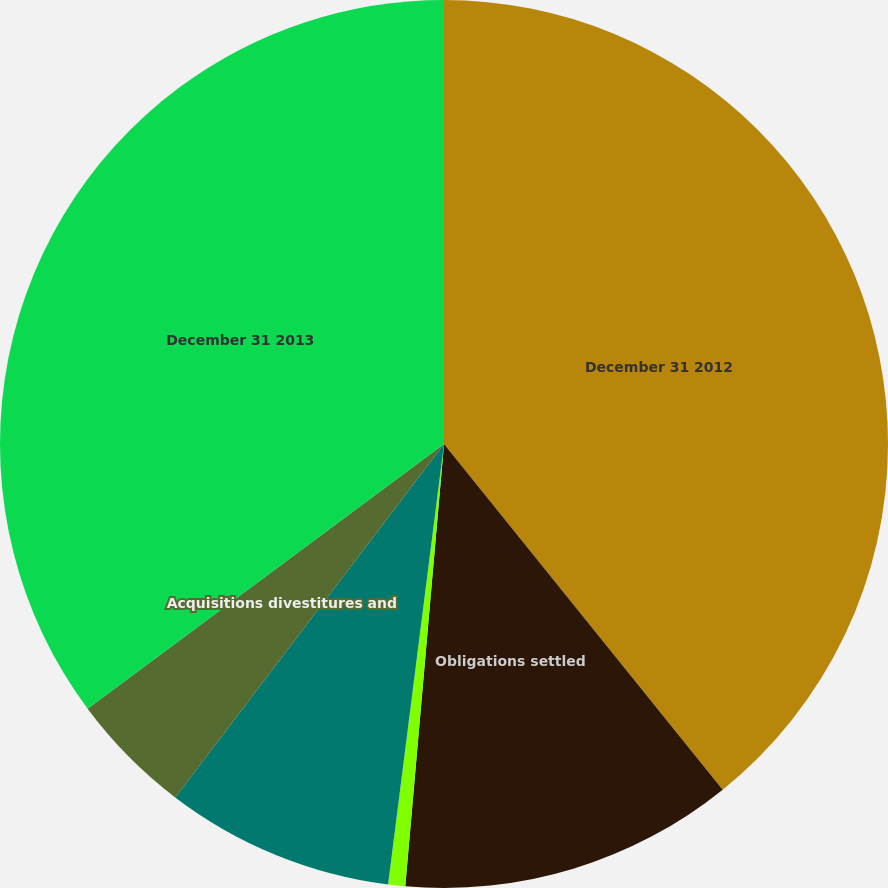<chart> <loc_0><loc_0><loc_500><loc_500><pie_chart><fcel>December 31 2012<fcel>Obligations settled<fcel>Interest accretion<fcel>Revisions in estimates and<fcel>Acquisitions divestitures and<fcel>December 31 2013<nl><fcel>39.2%<fcel>12.19%<fcel>0.62%<fcel>8.34%<fcel>4.48%<fcel>35.17%<nl></chart> 